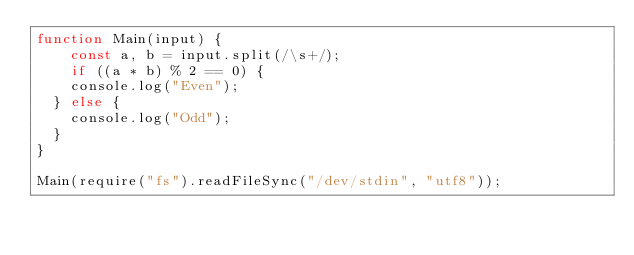<code> <loc_0><loc_0><loc_500><loc_500><_JavaScript_>function Main(input) {
    const a, b = input.split(/\s+/);
    if ((a * b) % 2 == 0) {
    console.log("Even");
  } else {
    console.log("Odd");
  }
}

Main(require("fs").readFileSync("/dev/stdin", "utf8"));
</code> 